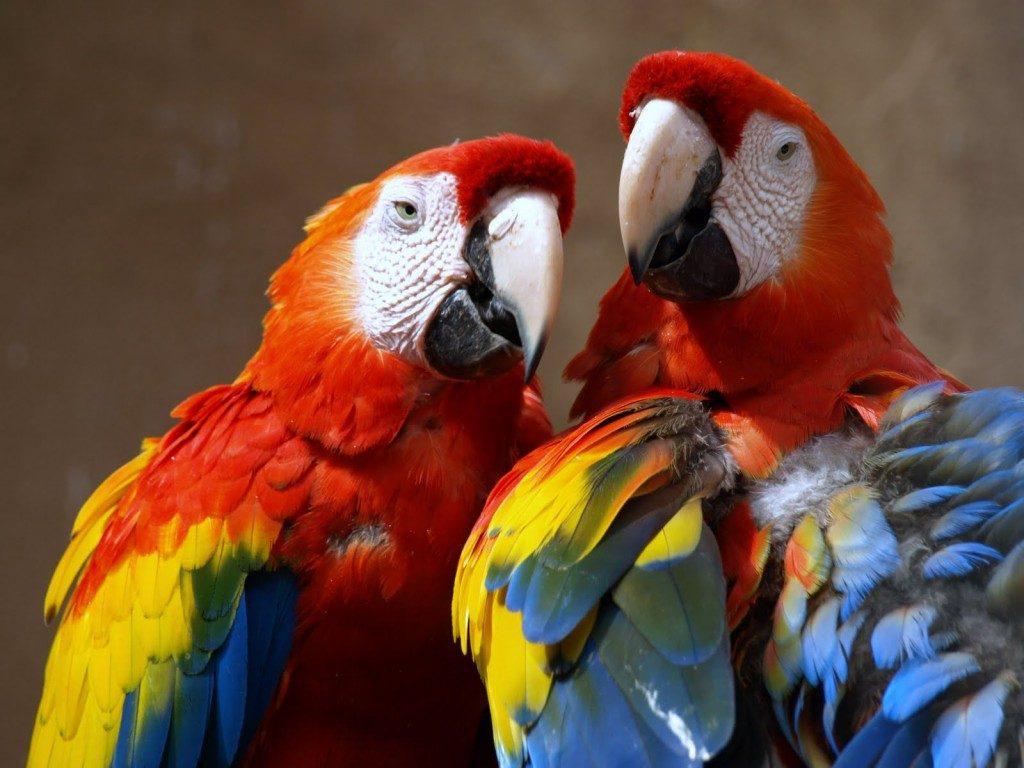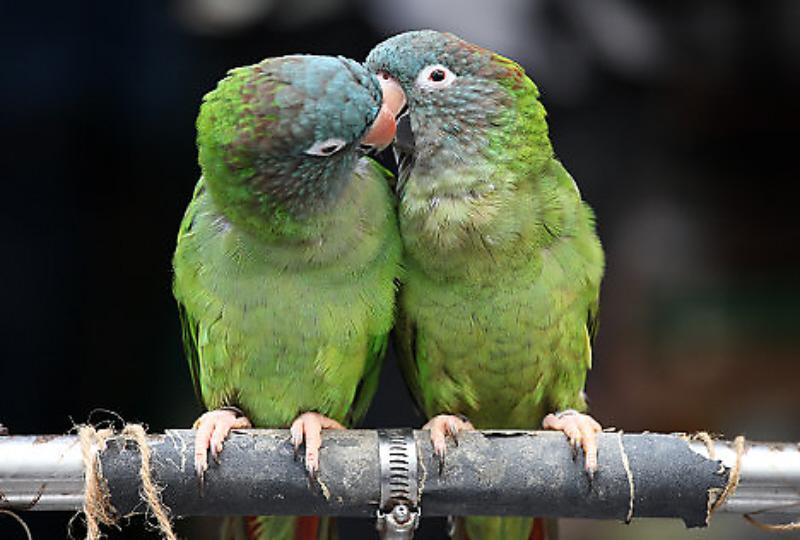The first image is the image on the left, the second image is the image on the right. Analyze the images presented: Is the assertion "An image shows a single parrot in flight." valid? Answer yes or no. No. 